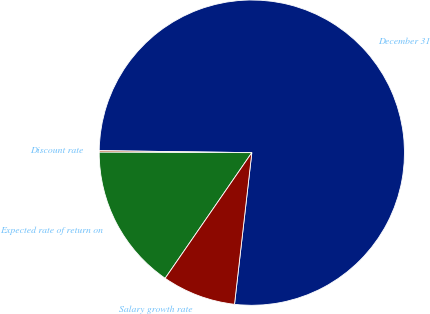Convert chart to OTSL. <chart><loc_0><loc_0><loc_500><loc_500><pie_chart><fcel>December 31<fcel>Discount rate<fcel>Expected rate of return on<fcel>Salary growth rate<nl><fcel>76.6%<fcel>0.16%<fcel>15.44%<fcel>7.8%<nl></chart> 